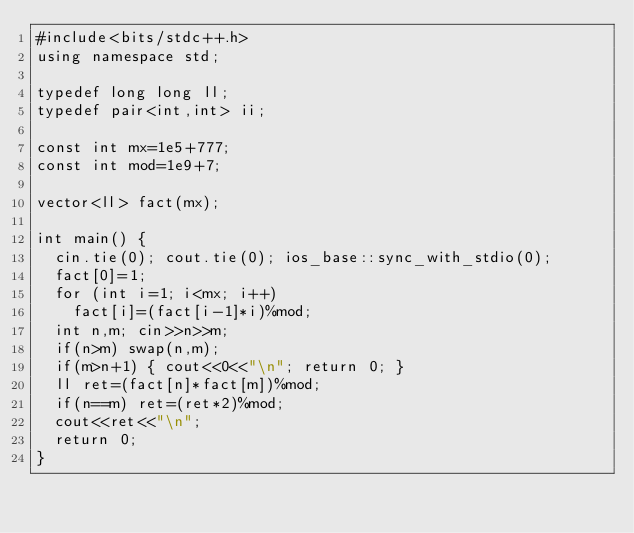Convert code to text. <code><loc_0><loc_0><loc_500><loc_500><_C++_>#include<bits/stdc++.h>
using namespace std;

typedef long long ll;
typedef pair<int,int> ii;

const int mx=1e5+777;
const int mod=1e9+7;

vector<ll> fact(mx);

int main() {
	cin.tie(0); cout.tie(0); ios_base::sync_with_stdio(0);
	fact[0]=1;
	for (int i=1; i<mx; i++)
		fact[i]=(fact[i-1]*i)%mod;
	int n,m; cin>>n>>m;
	if(n>m) swap(n,m);
	if(m>n+1) { cout<<0<<"\n"; return 0; }
	ll ret=(fact[n]*fact[m])%mod;
	if(n==m) ret=(ret*2)%mod;
	cout<<ret<<"\n";
	return 0;
}</code> 